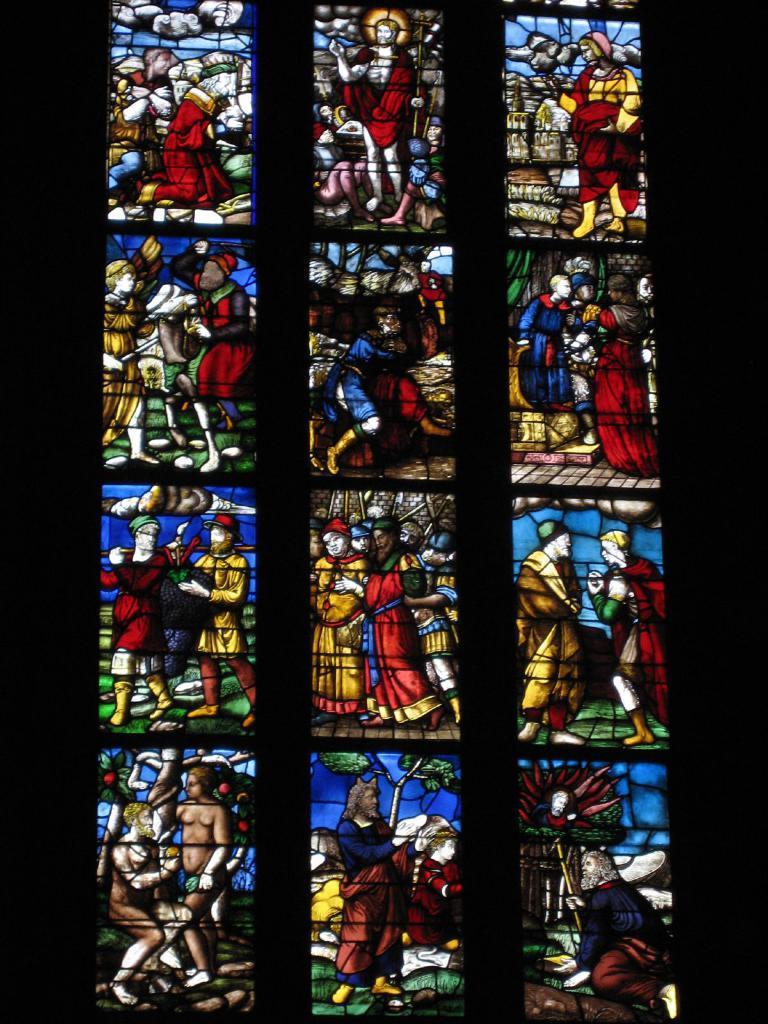Can you describe this image briefly? In this image there is a glass window having painting of few persons on it. 